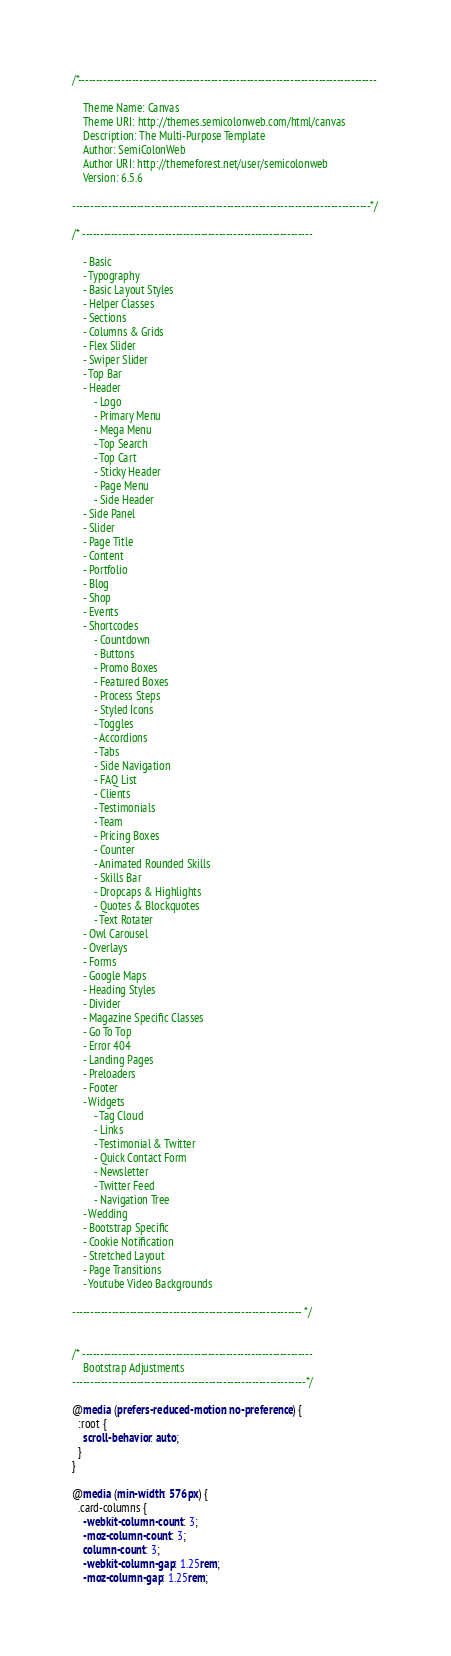Convert code to text. <code><loc_0><loc_0><loc_500><loc_500><_CSS_>/*-----------------------------------------------------------------------------------

	Theme Name: Canvas
	Theme URI: http://themes.semicolonweb.com/html/canvas
	Description: The Multi-Purpose Template
	Author: SemiColonWeb
	Author URI: http://themeforest.net/user/semicolonweb
	Version: 6.5.6

-----------------------------------------------------------------------------------*/

/* ----------------------------------------------------------------

	- Basic
	- Typography
	- Basic Layout Styles
	- Helper Classes
	- Sections
	- Columns & Grids
	- Flex Slider
	- Swiper Slider
	- Top Bar
	- Header
		- Logo
		- Primary Menu
		- Mega Menu
		- Top Search
		- Top Cart
		- Sticky Header
		- Page Menu
		- Side Header
	- Side Panel
	- Slider
	- Page Title
	- Content
	- Portfolio
	- Blog
	- Shop
	- Events
	- Shortcodes
		- Countdown
		- Buttons
		- Promo Boxes
		- Featured Boxes
		- Process Steps
		- Styled Icons
		- Toggles
		- Accordions
		- Tabs
		- Side Navigation
		- FAQ List
		- Clients
		- Testimonials
		- Team
		- Pricing Boxes
		- Counter
		- Animated Rounded Skills
		- Skills Bar
		- Dropcaps & Highlights
		- Quotes & Blockquotes
		- Text Rotater
	- Owl Carousel
	- Overlays
	- Forms
	- Google Maps
	- Heading Styles
	- Divider
	- Magazine Specific Classes
	- Go To Top
	- Error 404
	- Landing Pages
	- Preloaders
	- Footer
	- Widgets
		- Tag Cloud
		- Links
		- Testimonial & Twitter
		- Quick Contact Form
		- Newsletter
		- Twitter Feed
		- Navigation Tree
	- Wedding
	- Bootstrap Specific
	- Cookie Notification
	- Stretched Layout
	- Page Transitions
	- Youtube Video Backgrounds

---------------------------------------------------------------- */


/* ----------------------------------------------------------------
	Bootstrap Adjustments
-----------------------------------------------------------------*/

@media (prefers-reduced-motion: no-preference) {
  :root {
    scroll-behavior: auto;
  }
}

@media (min-width: 576px) {
  .card-columns {
    -webkit-column-count: 3;
    -moz-column-count: 3;
    column-count: 3;
    -webkit-column-gap: 1.25rem;
    -moz-column-gap: 1.25rem;</code> 